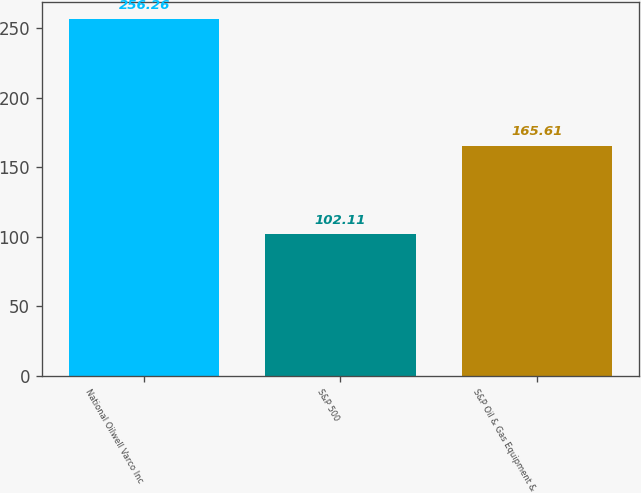Convert chart. <chart><loc_0><loc_0><loc_500><loc_500><bar_chart><fcel>National Oilwell Varco Inc<fcel>S&P 500<fcel>S&P Oil & Gas Equipment &<nl><fcel>256.26<fcel>102.11<fcel>165.61<nl></chart> 